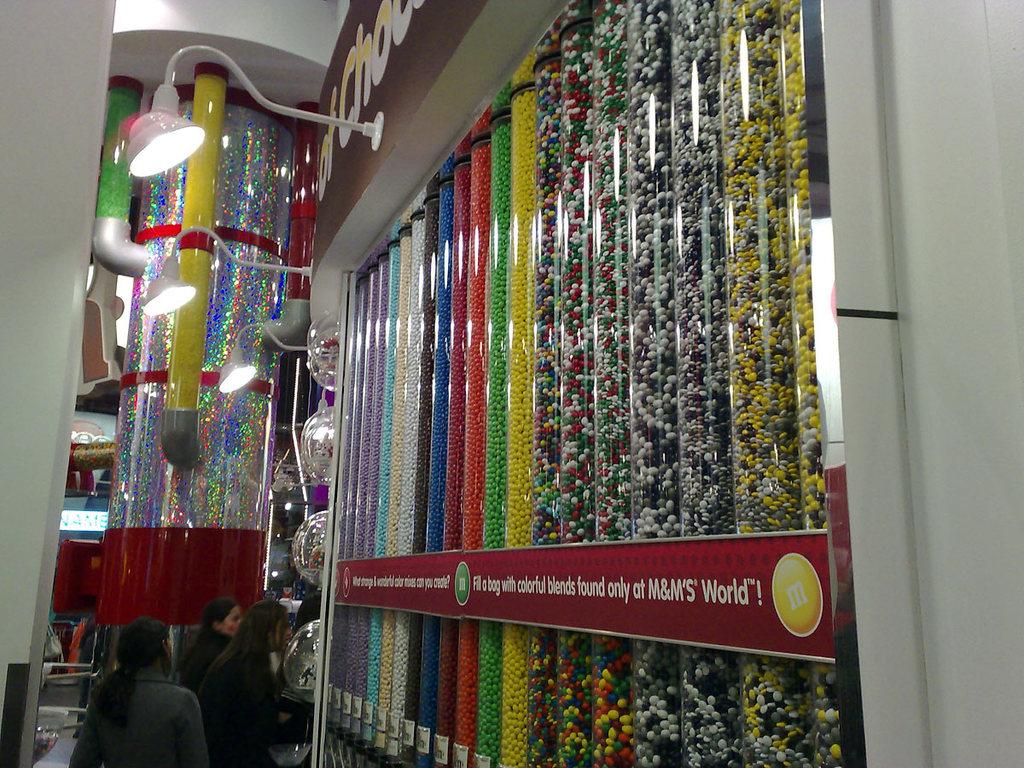What is the last right word on the red?
Keep it short and to the point. World. 